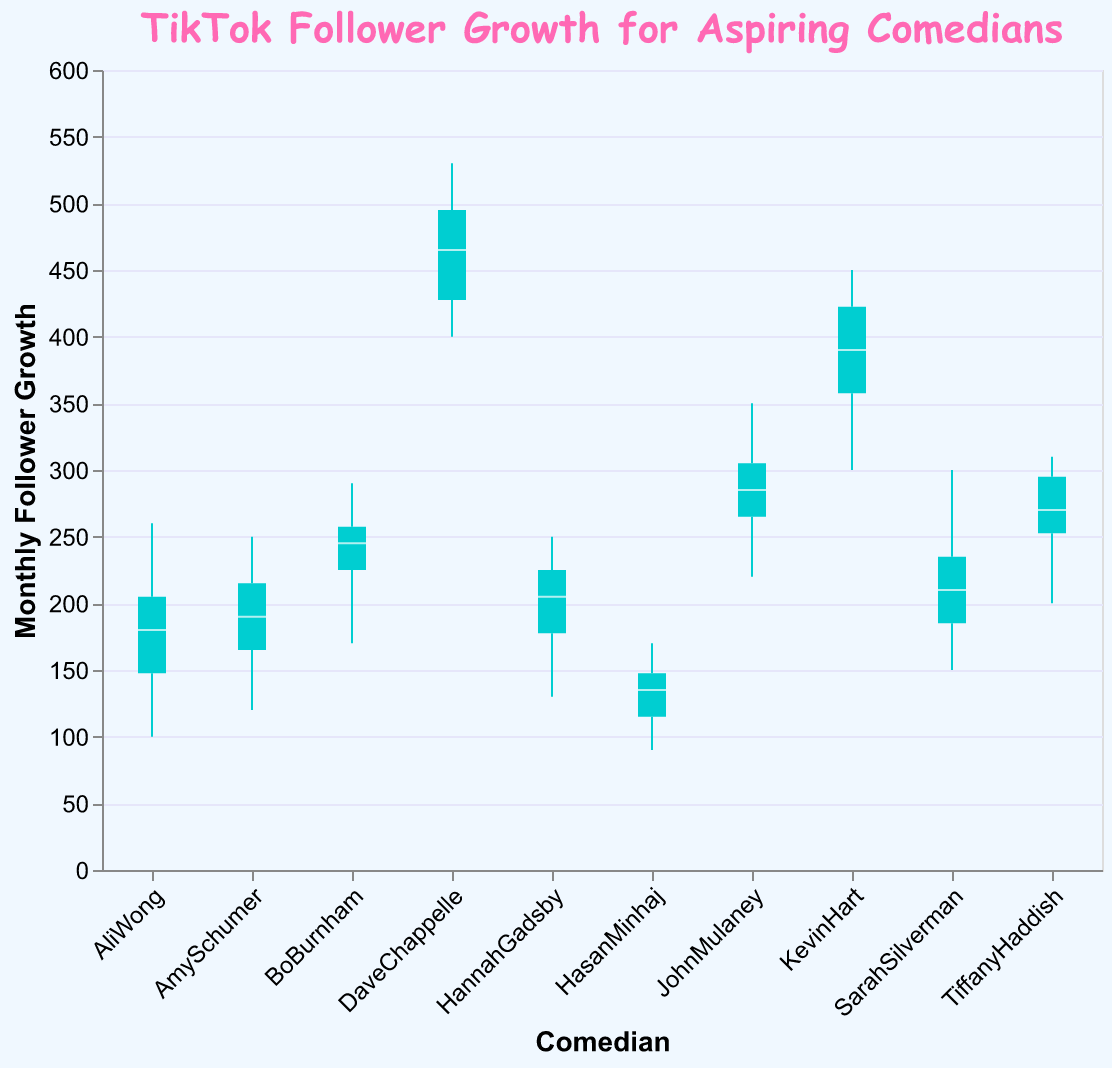What's the title of the plot? The title of the plot is usually the largest text and positioned at the top of the figure. Here, it is a text element that reads "TikTok Follower Growth for Aspiring Comedians".
Answer: TikTok Follower Growth for Aspiring Comedians What does the y-axis represent? The y-axis is labeled "Monthly Follower Growth", indicating it represents the number of new followers each comedian gained monthly on TikTok.
Answer: Monthly Follower Growth Which comedian has the highest median monthly follower growth? In a box plot, the median is marked by the line inside the box. DaveChappelle's box plot has the highest median line compared to other comedians.
Answer: DaveChappelle Which comedian has the largest range of monthly follower growth? The range in a box plot is represented by the length from the minimum to the maximum value. DaveChappelle's box plot has the largest spread from the lowest to the highest point.
Answer: DaveChappelle How many comedians have a median monthly follower growth above 200? The median is the line within the box. The comedians above the 200 mark are DaveChappelle, KevinHart, JohnMulaney, and TiffanyHaddish.
Answer: Four What is the overall color scheme used for the box plots? The box plots are colored, with the median marked by a specific color, and the boxes filled differently. The boxes are turquoise, and the median lines are bright pink.
Answer: Turquoise and bright pink Which comedian has the smallest interquartile range (IQR)? The IQR is represented by the size of the box in the plot. HasanMinhaj has the smallest box, indicating the smallest IQR.
Answer: HasanMinhaj Which comedians have an interquartile range (IQR) spanning from below 200 to above 200? The IQR spans from the bottom to the top of the box. Those boxes that cross the 200 mark are AlyWong, KevinHart, AmySchumer, BoBurnham, and SarahSilverman.
Answer: AliWong, KevinHart, AmySchumer, BoBurnham, and SarahSilverman What's the difference in the median monthly follower growth between KevinHart and HasanMinhaj? The median for KevinHart is at 365 and for HasanMinhaj is at 130. So, the difference is 365 - 130 = 235.
Answer: 235 Which comedian appears to have the most consistent monthly follower growth? Consistency is indicated by a small IQR and small range between the minimum and maximum points. HasanMinhaj shows both a small IQR and small overall range.
Answer: HasanMinhaj 